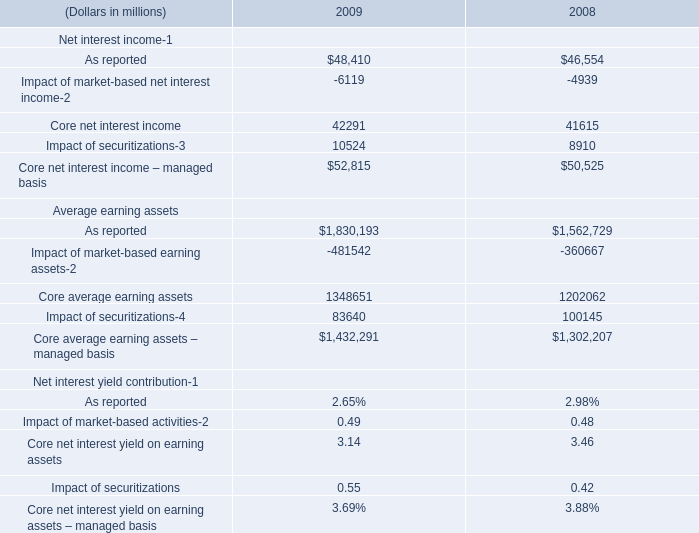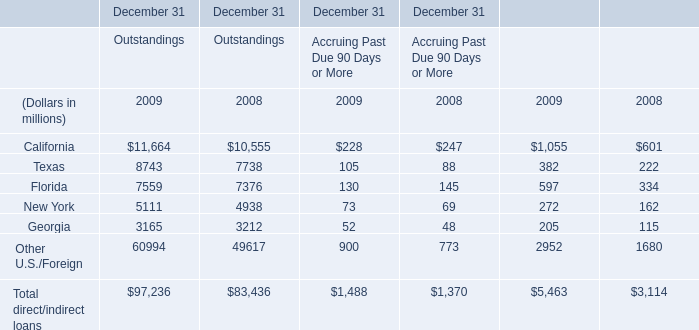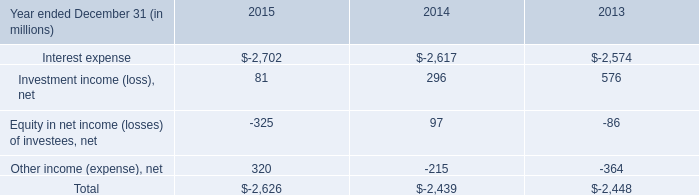what would the investment income ( loss ) have been in 2014 without the gain from the sale of the investment in clearwire corporation in 2013? 
Computations: (296 - 443)
Answer: -147.0. What's the average of the New York for Outstandings in the years where Core net interest income – managed basis for Net interest income-1 is greater than 0? (in million) 
Computations: ((5111 + 4938) / 2)
Answer: 5024.5. 